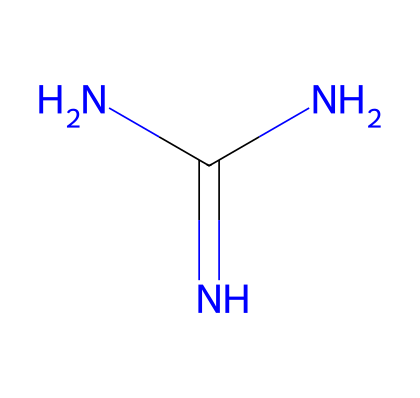How many nitrogen atoms are in guanidine? The SMILES representation shows three 'N' symbols, indicating there are three nitrogen atoms present in the compound.
Answer: 3 What is the functional group of guanidine? The SMILES notation indicates that guanidine contains a primary amino group (NH2) and two secondary amino groups (N). Therefore it can be classified under amino compounds.
Answer: amino What is the total number of atoms in guanidine? Counting the atoms represented in the SMILES—3 nitrogen (N) atoms and 1 carbon (C) atom—gives a total of 4 atoms in guanidine.
Answer: 4 What is the hybridization of the carbon atom in guanidine? The carbon atom in guanidine is bonded to two nitrogen atoms, which results in a trigonal planar arrangement. This indicates sp2 hybridization for the carbon atom.
Answer: sp2 Is guanidine a strong or weak base? Guanidine is widely recognized as a strong organic base due to its ability to accept protons readily in aqueous solutions, owing to its nitrogen atoms' basicity.
Answer: strong How many hydrogen atoms are present in guanidine? In guanidine, the three nitrogen atoms are bonded to a total of six hydrogen atoms, fulfilling their valency requirement.
Answer: 6 What makes guanidine a superbasic compound? Guanidine's exceptional proton-accepting ability stems from its highly stable resonance structures, facilitated by the presence of multiple nitrogen atoms.
Answer: resonance stability 